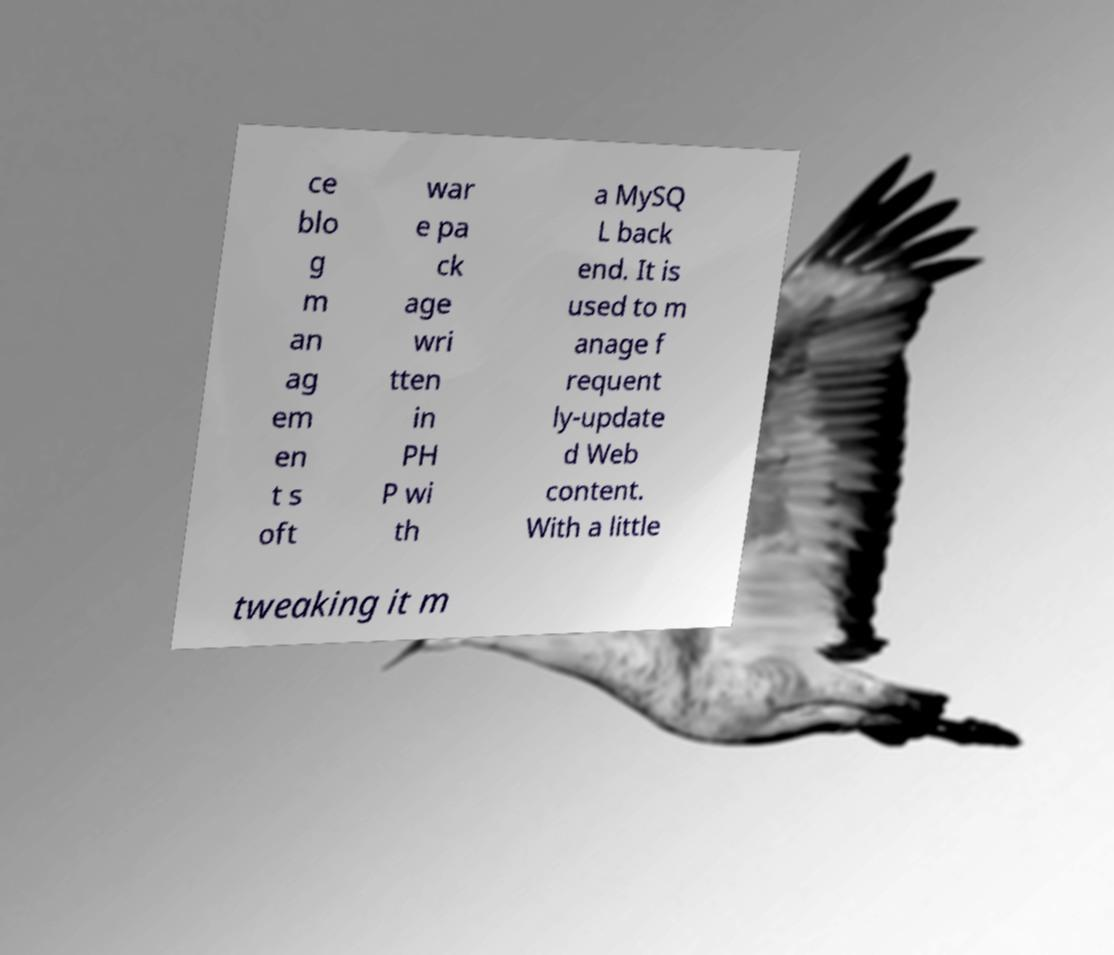Could you extract and type out the text from this image? ce blo g m an ag em en t s oft war e pa ck age wri tten in PH P wi th a MySQ L back end. It is used to m anage f requent ly-update d Web content. With a little tweaking it m 